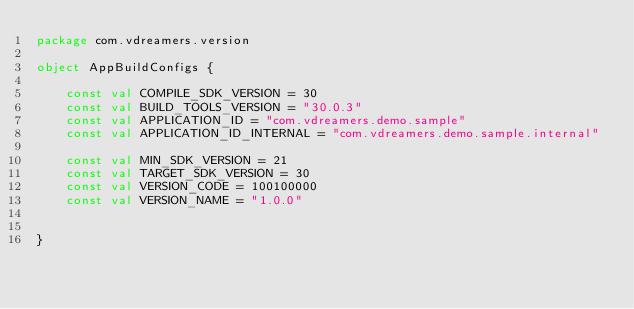Convert code to text. <code><loc_0><loc_0><loc_500><loc_500><_Kotlin_>package com.vdreamers.version

object AppBuildConfigs {

    const val COMPILE_SDK_VERSION = 30
    const val BUILD_TOOLS_VERSION = "30.0.3"
    const val APPLICATION_ID = "com.vdreamers.demo.sample"
    const val APPLICATION_ID_INTERNAL = "com.vdreamers.demo.sample.internal"

    const val MIN_SDK_VERSION = 21
    const val TARGET_SDK_VERSION = 30
    const val VERSION_CODE = 100100000
    const val VERSION_NAME = "1.0.0"


}</code> 